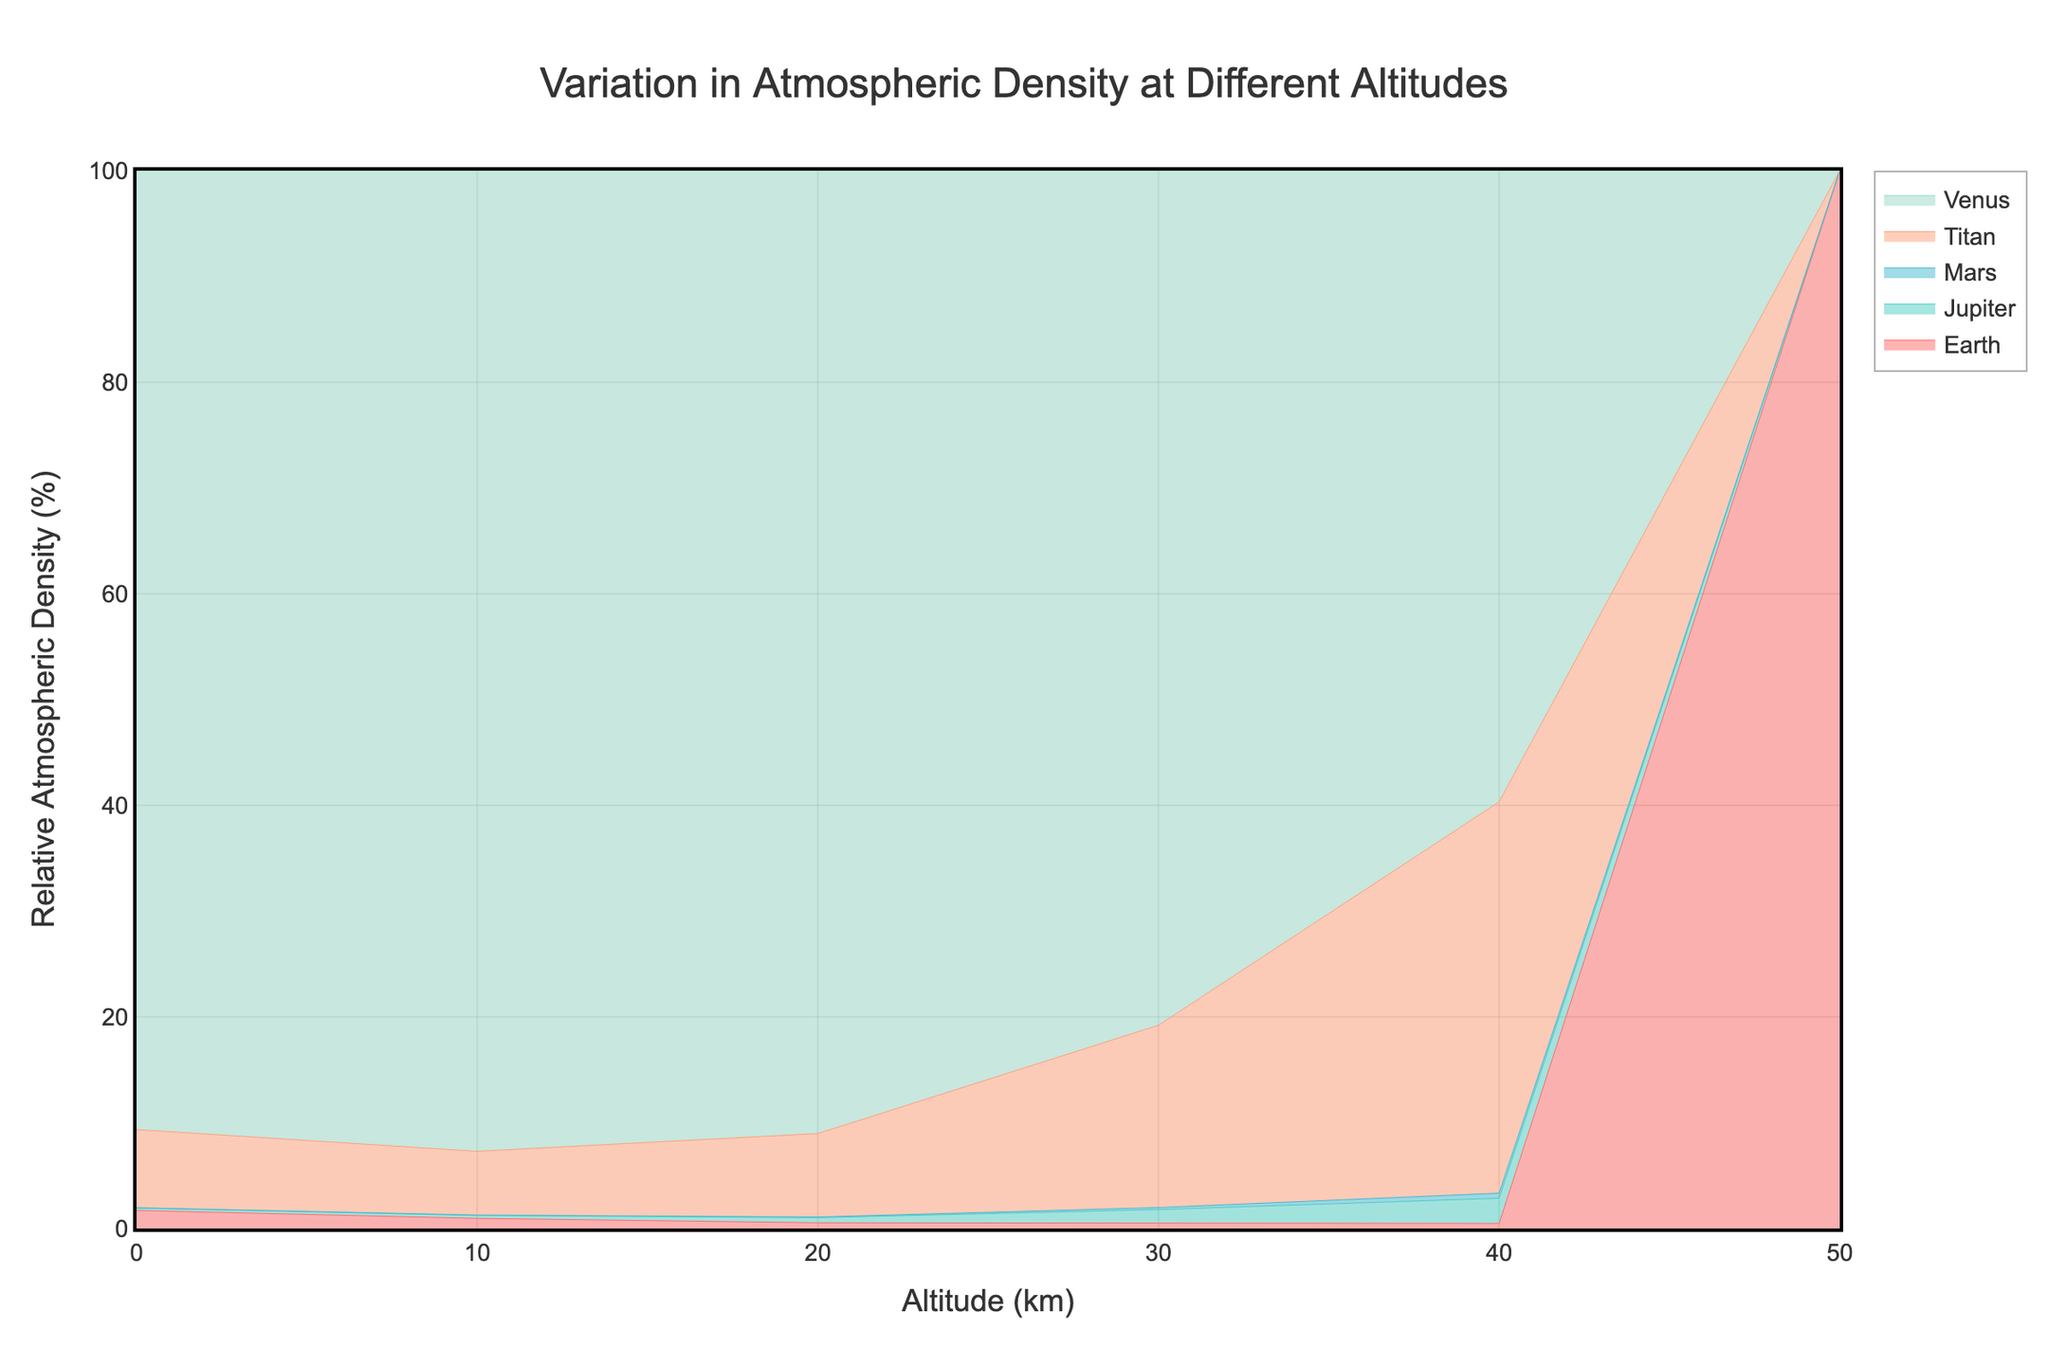What's the title of the figure? The title is typically displayed at the top of the figure. In this case, it reads "Variation in Atmospheric Density at Different Altitudes".
Answer: Variation in Atmospheric Density at Different Altitudes Which planet starts with the highest atmospheric density at 0 km altitude? By comparing the values for each planet at 0 km altitude, Venus has the highest atmospheric density with a value of 65 kg/m³.
Answer: Venus What is the trend of Earth's atmospheric density with increasing altitude? Observing the stream graph, the density for Earth decreases as altitude increases. It starts from 1.225 kg/m³ at 0 km and continuously decreases to 0.001027 kg/m³ at 50 km.
Answer: Decreasing How does the atmospheric density of Mars at 10 km compare to that of Titan at the same altitude? By looking at the values on the figure, Mars has an atmospheric density of 0.015 kg/m³ at 10 km, while Titan has an atmospheric density of 2.6 kg/m³ at 10 km. Titan's density is higher.
Answer: Titan's density is higher Which planet shows the steepest decline in atmospheric density from 0 km to 40 km? To determine the steepest decline, we look at the differences over the altitude range. Venus's density drops from 65 kg/m³ at 0 km to 0.5 kg/m³ at 40 km, the steepest decline among the planets.
Answer: Venus At what altitude does Earth's atmospheric density fall below 0.1 kg/m³? Observing Earth's density values, at 20 km altitude, Earth’s atmospheric density is 0.08891 kg/m³. This is the first point where the density falls below 0.1 kg/m³.
Answer: 20 km Can you identify the planet with the thickest atmosphere relative to its surface and compare it to Earth at 40 km altitude? Venus has the thickest atmosphere relative to its surface with 65 kg/m³ at 0 km. Comparing this to Earth's atmospheric density at 40 km, which is 0.003996 kg/m³, Venus is significantly denser.
Answer: Venus is significantly denser What is the atmospheric density difference between Jupiter and Earth at 10 km altitude? The density at 10 km for Jupiter is 0.12 kg/m³, and for Earth, it is 0.4135 kg/m³. The difference is 0.4135 - 0.12 = 0.2935 kg/m³.
Answer: 0.2935 kg/m³ How does the percentage of relative atmospheric density change for Jupiter from 0 to 40 km? Jupiter shows a decreasing trend in absolute density from 0.16 kg/m³ at 0 km to 0.02 kg/m³ at 40 km. Since this is a relative percentage on the plot, visual inspection reveals a reduction in the percentage area under Jupiter as altitude increases.
Answer: Decreasing What's the sum of atmospheric densities of Titan and Mars at 30 km altitude? At 30 km, Titan's density is 0.64 kg/m³, and Mars's density is 0.007 kg/m³. Summing them gives 0.64 + 0.007 = 0.647 kg/m³.
Answer: 0.647 kg/m³ 